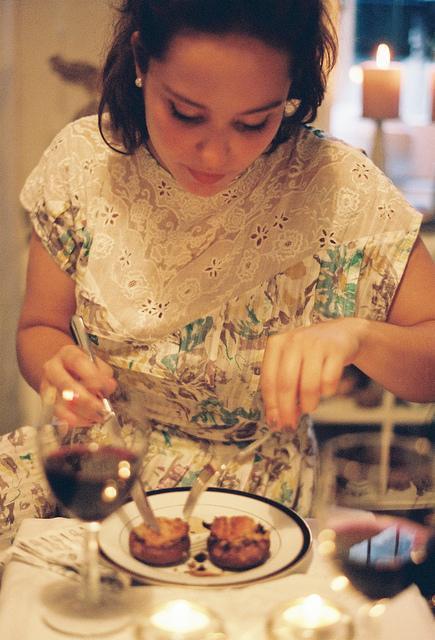How many donuts are visible?
Give a very brief answer. 2. How many wine glasses can you see?
Give a very brief answer. 2. 